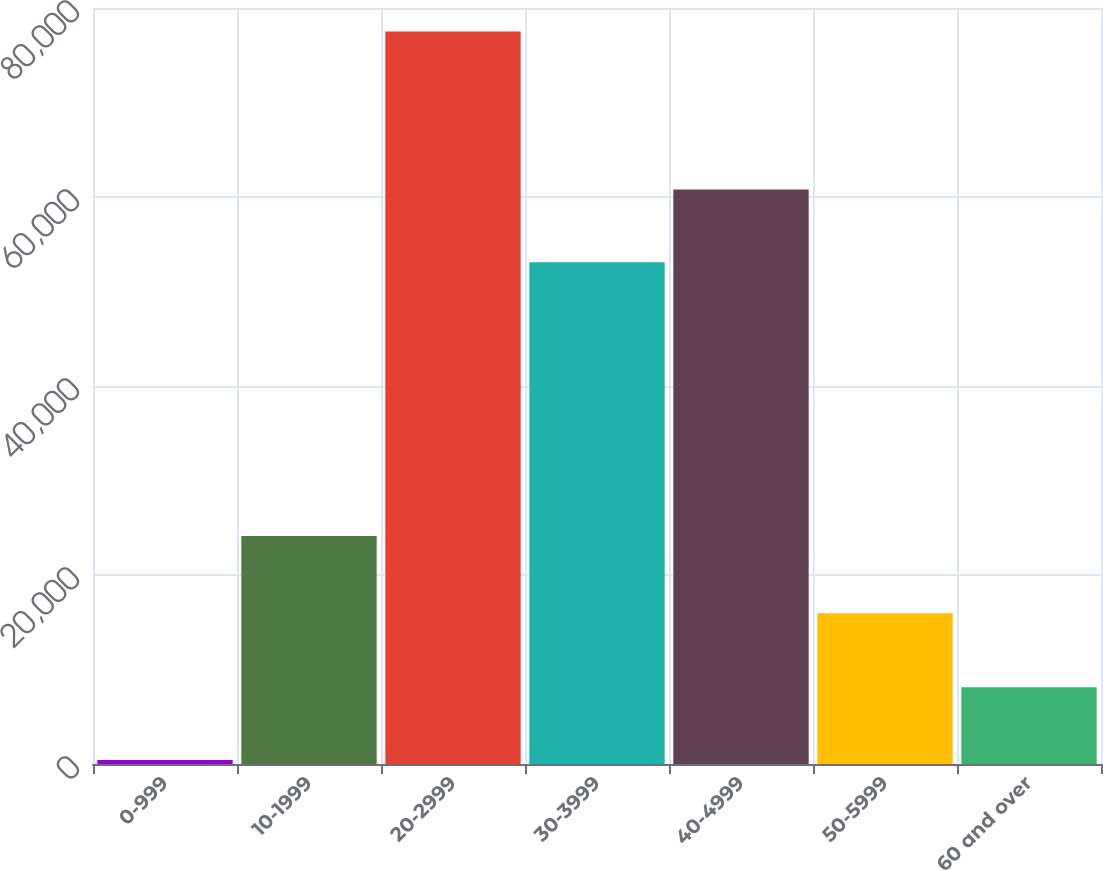Convert chart to OTSL. <chart><loc_0><loc_0><loc_500><loc_500><bar_chart><fcel>0-999<fcel>10-1999<fcel>20-2999<fcel>30-3999<fcel>40-4999<fcel>50-5999<fcel>60 and over<nl><fcel>415<fcel>24129<fcel>77523<fcel>53094<fcel>60804.8<fcel>15953<fcel>8125.8<nl></chart> 